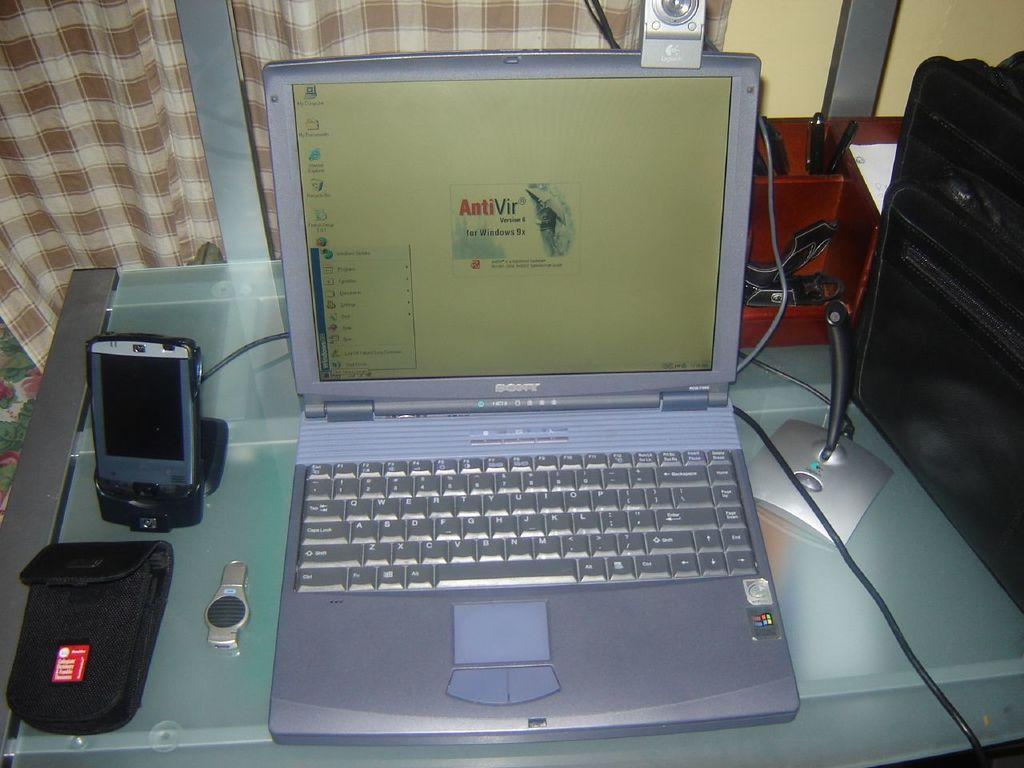Provide a one-sentence caption for the provided image. A Sony laptop with AntiVir version 6 for windows 9x on the screen. 